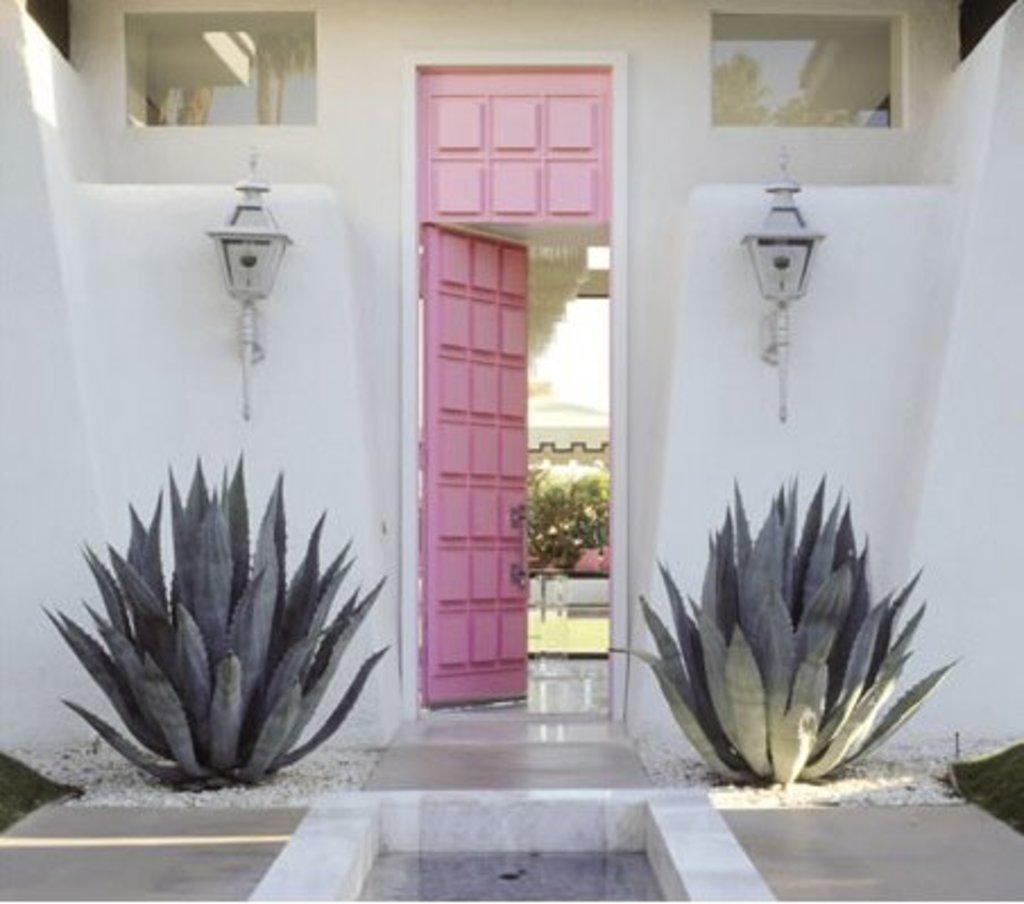Could you give a brief overview of what you see in this image? In this image we can see a door, plants, stones, electric lights attached to the walls, trees and ground. 